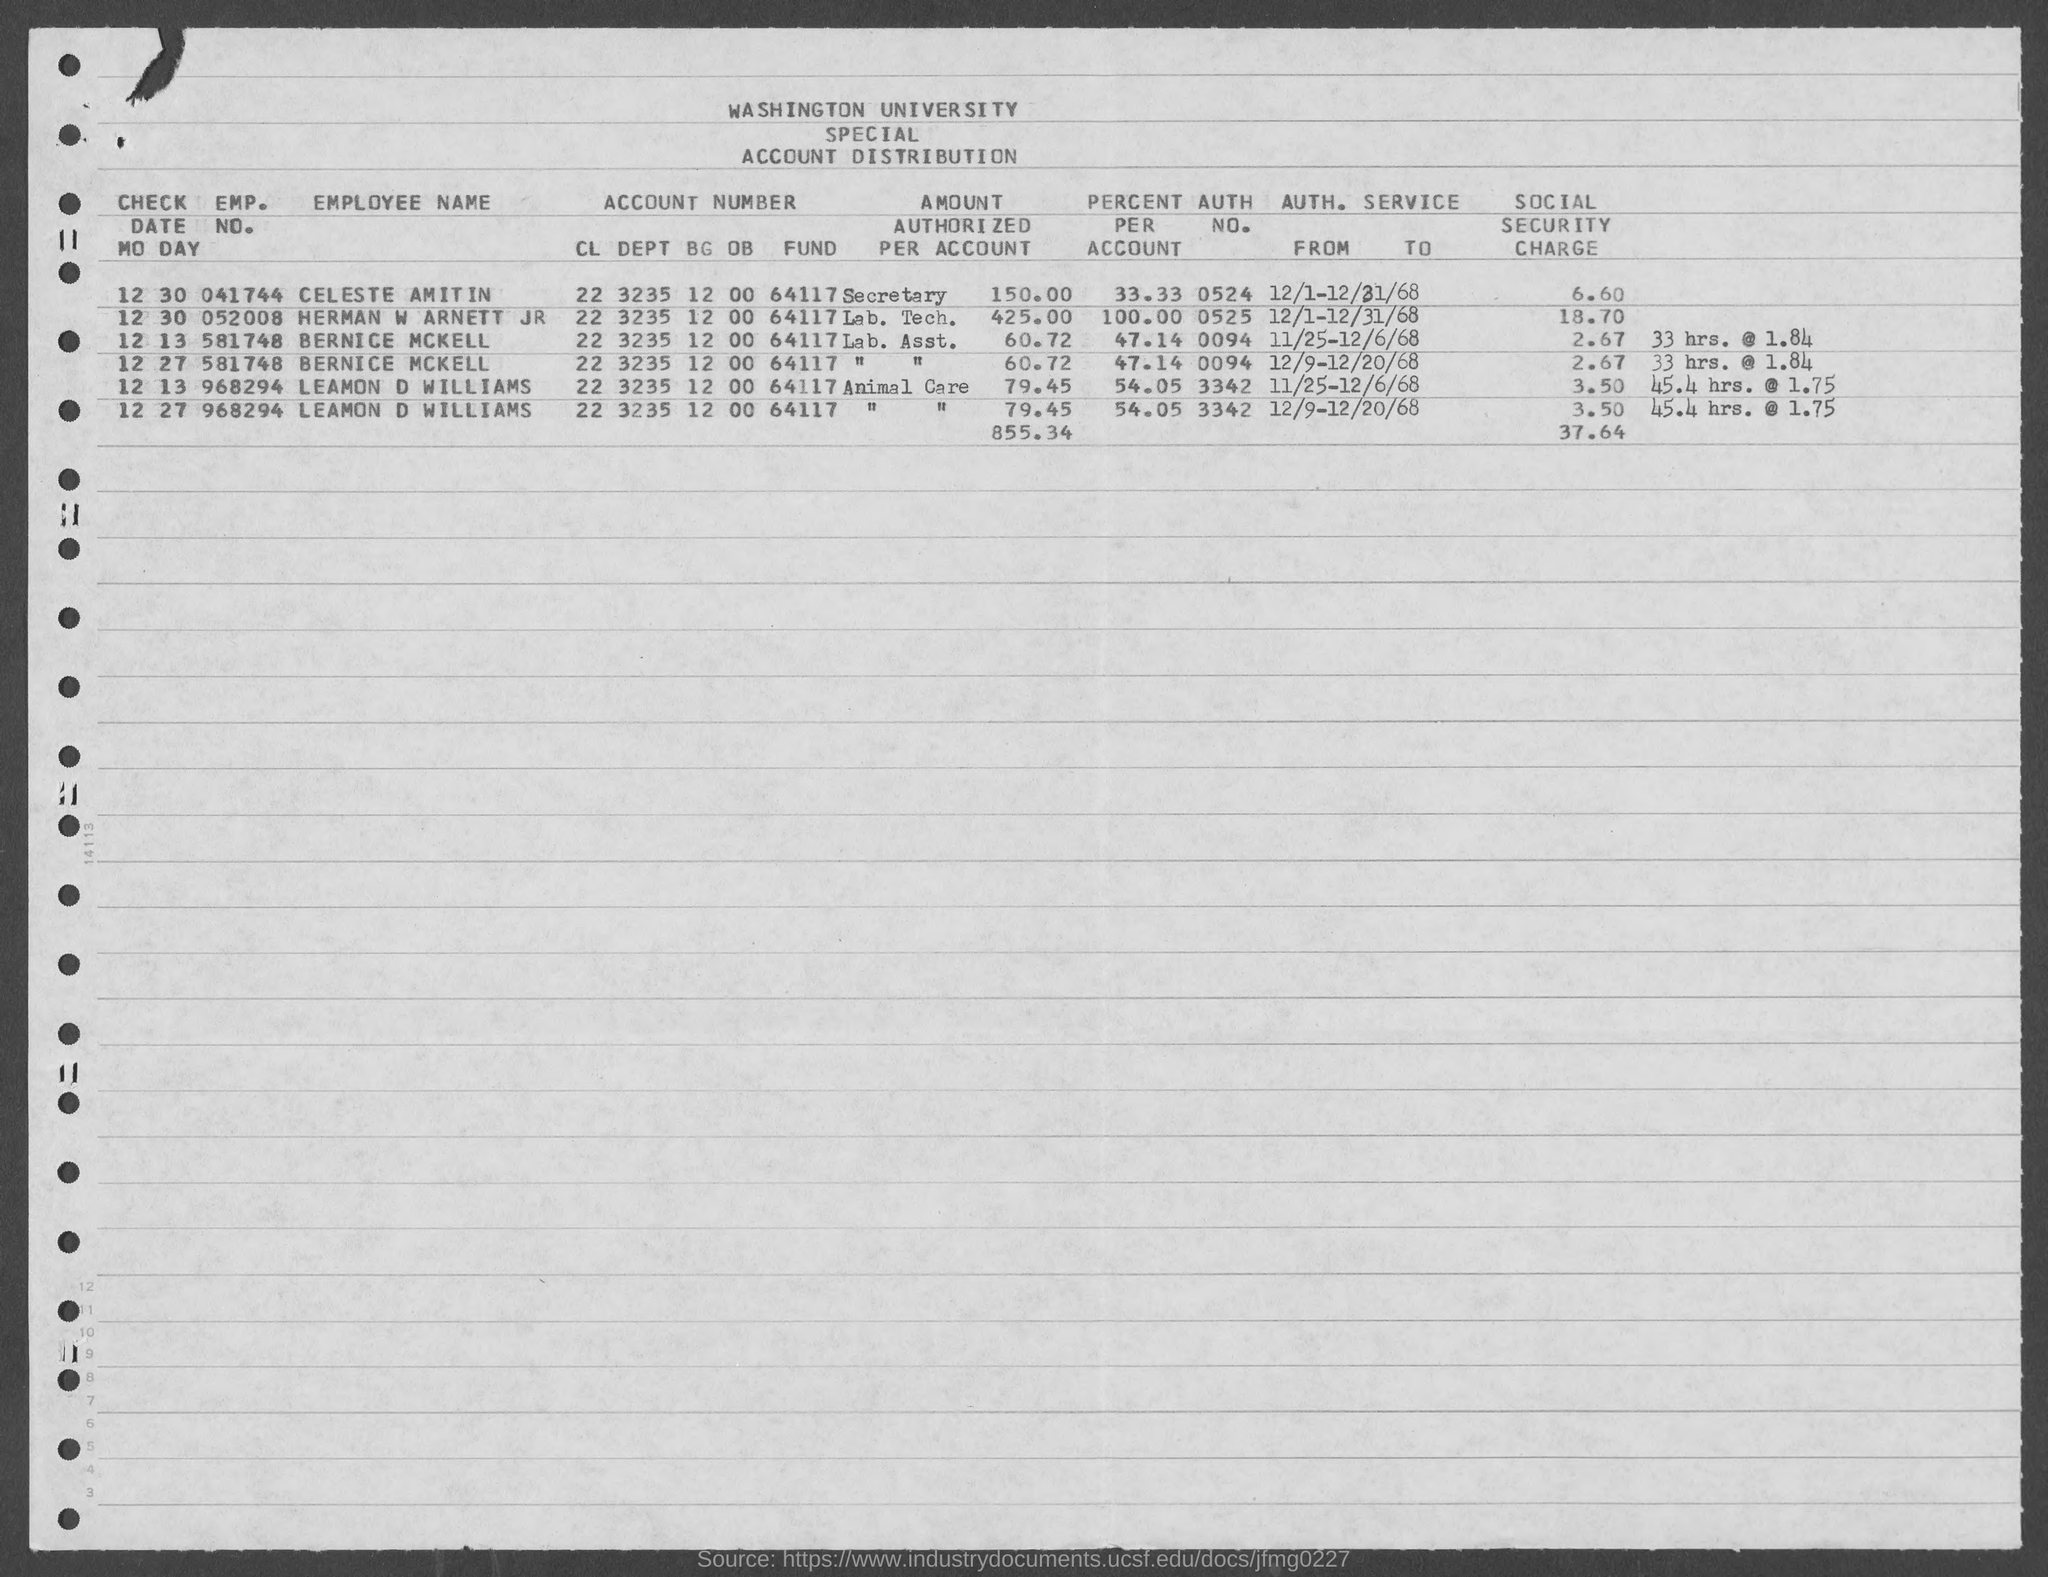What is the emp. no. of celeste amitin ?
Make the answer very short. 041744. What is the emp. no. of herman w arnett jr ?
Make the answer very short. 052008. What is the emp. no. of bernice mckell as mentioned in the given form ?
Your answer should be very brief. 581748. What is the emp. no. of leamon d williams ?
Provide a succinct answer. 968294. What is the auth. no. for bernice mckell ?
Make the answer very short. 0094. What is the auth.no. of celeste amitin ?
Your answer should be very brief. 0524. What is the auth. no. of leamon d williams ?
Offer a very short reply. 3342. What is the value of percent per account for bernice mckell as mentioned in the given form ?
Make the answer very short. 47.14. What is the value of percent per account for celeste amitin as mentioned in the given form ?
Give a very brief answer. 33.33. What is the value of percent per account for leamon d williams as mentioned in the given form ?
Your response must be concise. 54.05. 